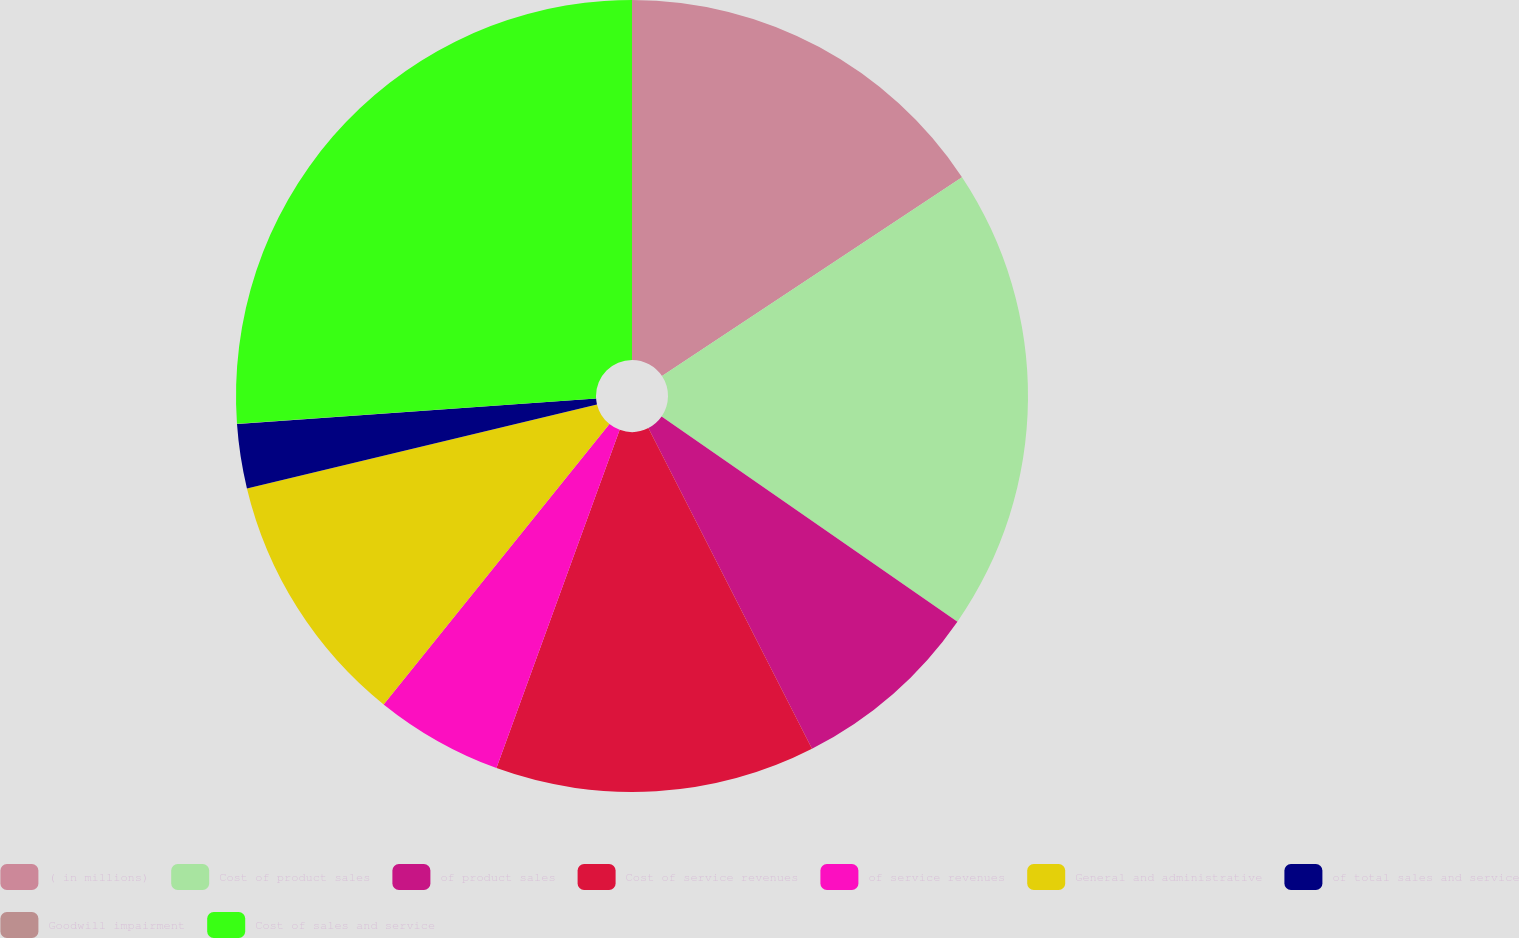Convert chart to OTSL. <chart><loc_0><loc_0><loc_500><loc_500><pie_chart><fcel>( in millions)<fcel>Cost of product sales<fcel>of product sales<fcel>Cost of service revenues<fcel>of service revenues<fcel>General and administrative<fcel>of total sales and service<fcel>Goodwill impairment<fcel>Cost of sales and service<nl><fcel>15.68%<fcel>18.97%<fcel>7.84%<fcel>13.07%<fcel>5.23%<fcel>10.46%<fcel>2.62%<fcel>0.01%<fcel>26.12%<nl></chart> 